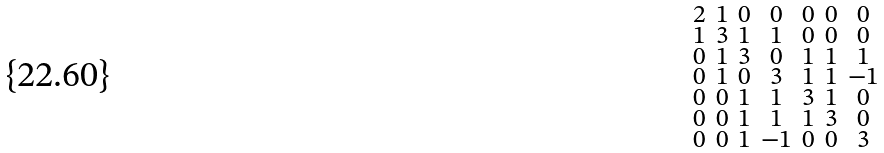<formula> <loc_0><loc_0><loc_500><loc_500>\begin{smallmatrix} 2 & 1 & 0 & 0 & 0 & 0 & 0 \\ 1 & 3 & 1 & 1 & 0 & 0 & 0 \\ 0 & 1 & 3 & 0 & 1 & 1 & 1 \\ 0 & 1 & 0 & 3 & 1 & 1 & - 1 \\ 0 & 0 & 1 & 1 & 3 & 1 & 0 \\ 0 & 0 & 1 & 1 & 1 & 3 & 0 \\ 0 & 0 & 1 & - 1 & 0 & 0 & 3 \end{smallmatrix}</formula> 